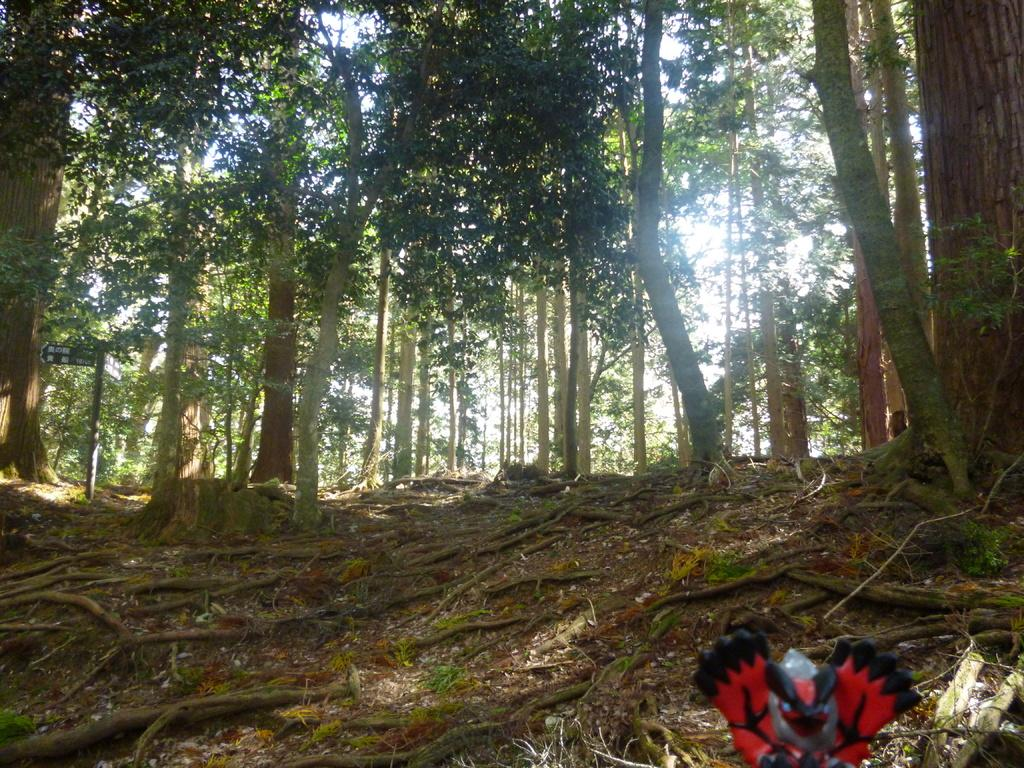What is located at the bottom of the image? There is an object at the bottom of the image. What type of natural vegetation can be seen in the image? There are trees in the image. What part of the trees is visible in the image? Tree roots are visible in the image. What is visible in the background of the image? The sky is visible in the image. Where is the crowd gathered in the image? There is no crowd present in the image. What type of ray is swimming in the image? There is no ray present in the image. 